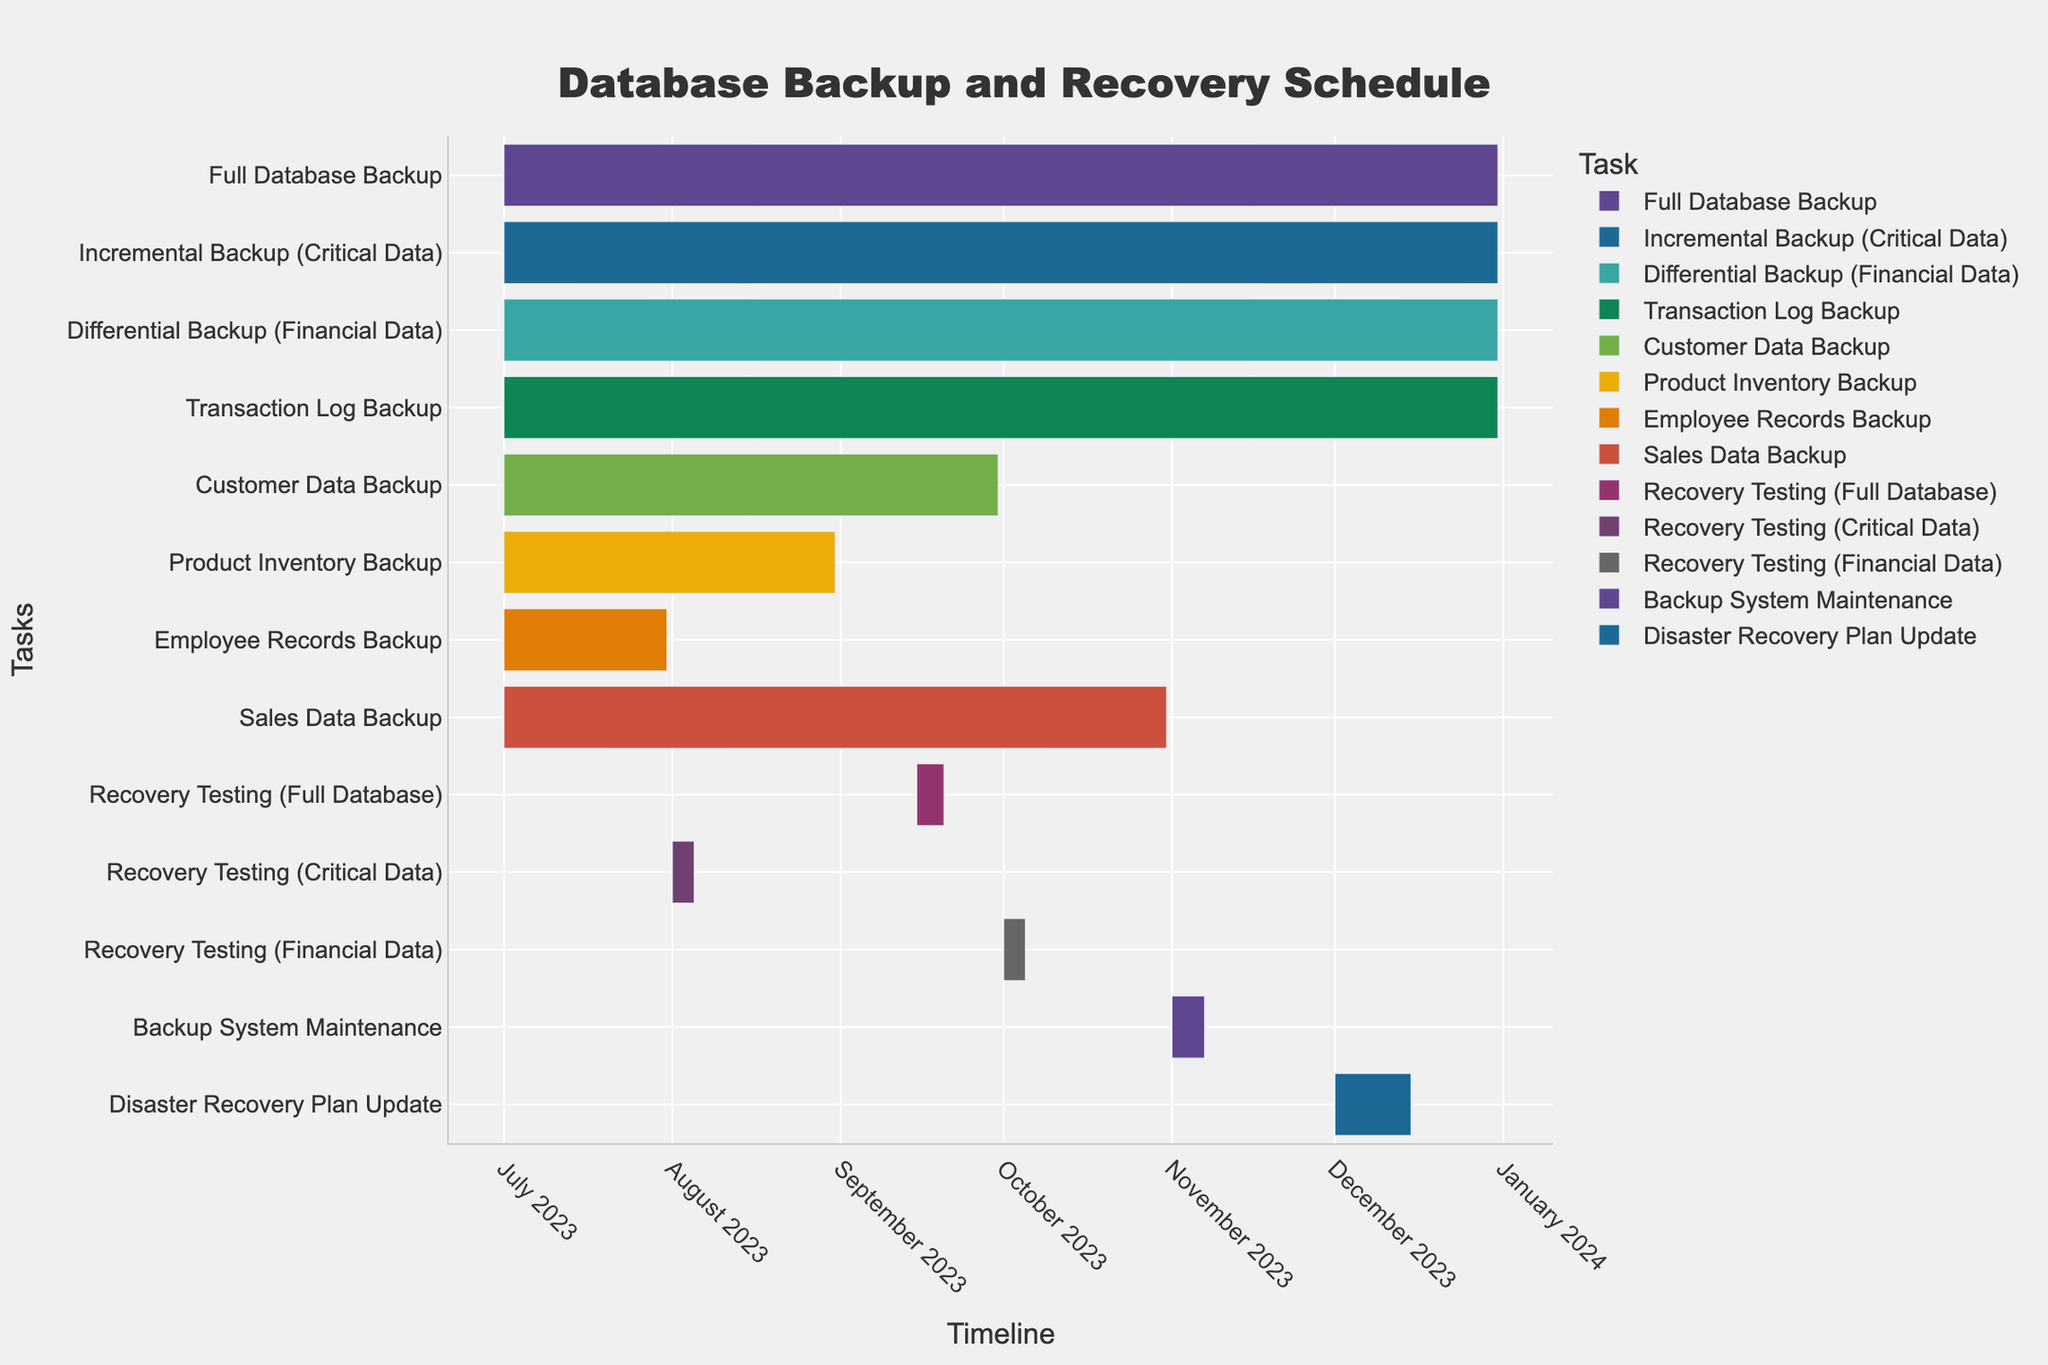What is the time span of the Full Database Backup? The Gantt Chart shows the Full Database Backup starting on July 1, 2023, and ending on December 31, 2023. To find this, locate the task "Full Database Backup" and read its start and end dates.
Answer: 6 months When does the Customer Data Backup end? The Gantt Chart indicates the Customer Data Backup task ends on September 30, 2023. To find this, locate the task "Customer Data Backup" and read its end date.
Answer: September 30, 2023 Which backup task has the shortest duration? The Employee Records Backup lasts from July 1, 2023, to July 31, 2023. To determine this, locate and compare the durations of all tasks. The Employee Records Backup spans 31 days, making it the shortest.
Answer: Employee Records Backup How many tasks end in September 2023? To determine the number of tasks ending in September 2023, count the tasks with an end date in that month. These are "Customer Data Backup" and "Recovery Testing (Full Database)". There are 2 such tasks.
Answer: 2 Which task starts first, Recovery Testing (Financial Data) or Backup System Maintenance? Compare the start dates of "Recovery Testing (Financial Data)" and "Backup System Maintenance". Recovery Testing (Financial Data) starts on October 1, 2023, while Backup System Maintenance starts on November 1, 2023. Therefore, Recovery Testing (Financial Data) starts first.
Answer: Recovery Testing (Financial Data) What is the duration of the Sales Data Backup? The Sales Data Backup starts on July 1, 2023, and ends on October 31, 2023. Calculate the duration by determining the number of days it spans, which is 123 days.
Answer: 123 days Which recovery testing tasks fall within Q3 2023? Q3 2023 includes July, August, and September. Check which recovery testing tasks fall within these months. "Recovery Testing (Critical Data)" occurs from August 1 to August 5, 2023, while "Recovery Testing (Full Database)" occurs from September 15 to September 20, 2023.
Answer: Recovery Testing (Critical Data), Recovery Testing (Full Database) Which tasks overlap with the Disaster Recovery Plan Update? The Disaster Recovery Plan Update spans December 1 to December 15, 2023. Check for tasks occurring during this period. Both "Full Database Backup" and "Incremental Backup (Critical Data)" overlap with this date range.
Answer: Full Database Backup, Incremental Backup (Critical Data) How long does the Backup System Maintenance task take? The Backup System Maintenance task starts on November 1, 2023, and ends on November 7, 2023. Calculate the duration by determining the number of days it spans, which is 7 days.
Answer: 7 days 